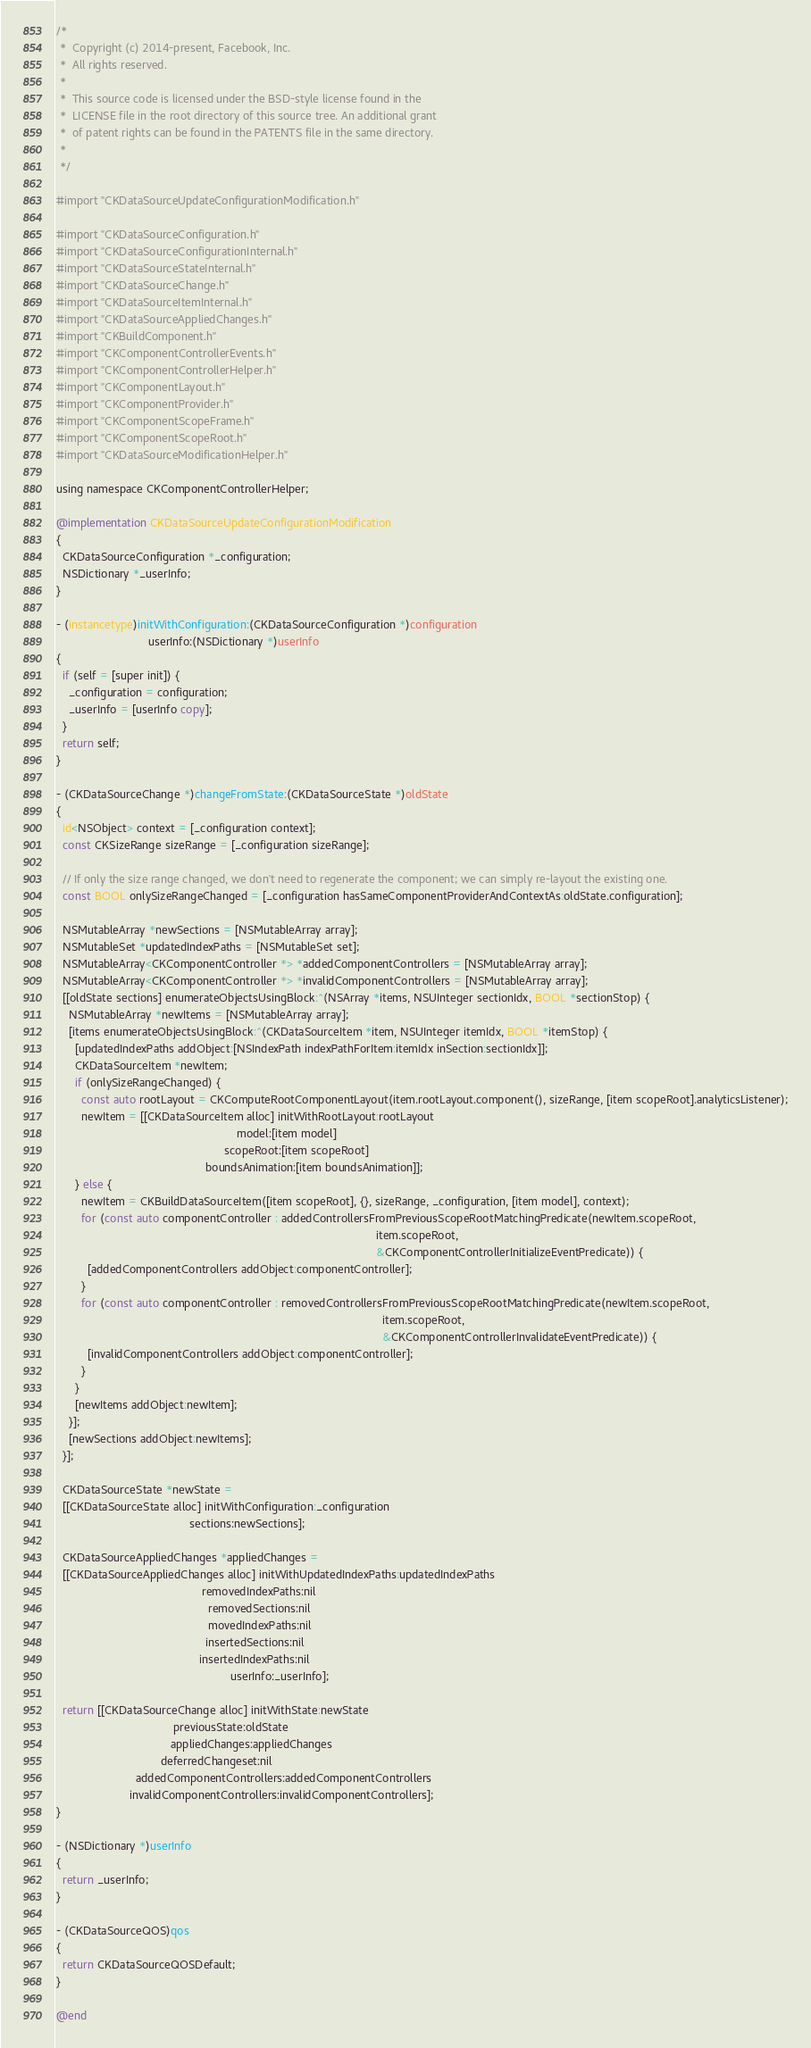<code> <loc_0><loc_0><loc_500><loc_500><_ObjectiveC_>/*
 *  Copyright (c) 2014-present, Facebook, Inc.
 *  All rights reserved.
 *
 *  This source code is licensed under the BSD-style license found in the
 *  LICENSE file in the root directory of this source tree. An additional grant
 *  of patent rights can be found in the PATENTS file in the same directory.
 *
 */

#import "CKDataSourceUpdateConfigurationModification.h"

#import "CKDataSourceConfiguration.h"
#import "CKDataSourceConfigurationInternal.h"
#import "CKDataSourceStateInternal.h"
#import "CKDataSourceChange.h"
#import "CKDataSourceItemInternal.h"
#import "CKDataSourceAppliedChanges.h"
#import "CKBuildComponent.h"
#import "CKComponentControllerEvents.h"
#import "CKComponentControllerHelper.h"
#import "CKComponentLayout.h"
#import "CKComponentProvider.h"
#import "CKComponentScopeFrame.h"
#import "CKComponentScopeRoot.h"
#import "CKDataSourceModificationHelper.h"

using namespace CKComponentControllerHelper;

@implementation CKDataSourceUpdateConfigurationModification
{
  CKDataSourceConfiguration *_configuration;
  NSDictionary *_userInfo;
}

- (instancetype)initWithConfiguration:(CKDataSourceConfiguration *)configuration
                             userInfo:(NSDictionary *)userInfo
{
  if (self = [super init]) {
    _configuration = configuration;
    _userInfo = [userInfo copy];
  }
  return self;
}

- (CKDataSourceChange *)changeFromState:(CKDataSourceState *)oldState
{
  id<NSObject> context = [_configuration context];
  const CKSizeRange sizeRange = [_configuration sizeRange];

  // If only the size range changed, we don't need to regenerate the component; we can simply re-layout the existing one.
  const BOOL onlySizeRangeChanged = [_configuration hasSameComponentProviderAndContextAs:oldState.configuration];

  NSMutableArray *newSections = [NSMutableArray array];
  NSMutableSet *updatedIndexPaths = [NSMutableSet set];
  NSMutableArray<CKComponentController *> *addedComponentControllers = [NSMutableArray array];
  NSMutableArray<CKComponentController *> *invalidComponentControllers = [NSMutableArray array];
  [[oldState sections] enumerateObjectsUsingBlock:^(NSArray *items, NSUInteger sectionIdx, BOOL *sectionStop) {
    NSMutableArray *newItems = [NSMutableArray array];
    [items enumerateObjectsUsingBlock:^(CKDataSourceItem *item, NSUInteger itemIdx, BOOL *itemStop) {
      [updatedIndexPaths addObject:[NSIndexPath indexPathForItem:itemIdx inSection:sectionIdx]];
      CKDataSourceItem *newItem;
      if (onlySizeRangeChanged) {
        const auto rootLayout = CKComputeRootComponentLayout(item.rootLayout.component(), sizeRange, [item scopeRoot].analyticsListener);
        newItem = [[CKDataSourceItem alloc] initWithRootLayout:rootLayout
                                                         model:[item model]
                                                     scopeRoot:[item scopeRoot]
                                               boundsAnimation:[item boundsAnimation]];
      } else {
        newItem = CKBuildDataSourceItem([item scopeRoot], {}, sizeRange, _configuration, [item model], context);
        for (const auto componentController : addedControllersFromPreviousScopeRootMatchingPredicate(newItem.scopeRoot,
                                                                                                     item.scopeRoot,
                                                                                                     &CKComponentControllerInitializeEventPredicate)) {
          [addedComponentControllers addObject:componentController];
        }
        for (const auto componentController : removedControllersFromPreviousScopeRootMatchingPredicate(newItem.scopeRoot,
                                                                                                       item.scopeRoot,
                                                                                                       &CKComponentControllerInvalidateEventPredicate)) {
          [invalidComponentControllers addObject:componentController];
        }
      }
      [newItems addObject:newItem];
    }];
    [newSections addObject:newItems];
  }];

  CKDataSourceState *newState =
  [[CKDataSourceState alloc] initWithConfiguration:_configuration
                                          sections:newSections];

  CKDataSourceAppliedChanges *appliedChanges =
  [[CKDataSourceAppliedChanges alloc] initWithUpdatedIndexPaths:updatedIndexPaths
                                              removedIndexPaths:nil
                                                removedSections:nil
                                                movedIndexPaths:nil
                                               insertedSections:nil
                                             insertedIndexPaths:nil
                                                       userInfo:_userInfo];

  return [[CKDataSourceChange alloc] initWithState:newState
                                     previousState:oldState
                                    appliedChanges:appliedChanges
                                 deferredChangeset:nil
                         addedComponentControllers:addedComponentControllers
                       invalidComponentControllers:invalidComponentControllers];
}

- (NSDictionary *)userInfo
{
  return _userInfo;
}

- (CKDataSourceQOS)qos
{
  return CKDataSourceQOSDefault;
}

@end
</code> 